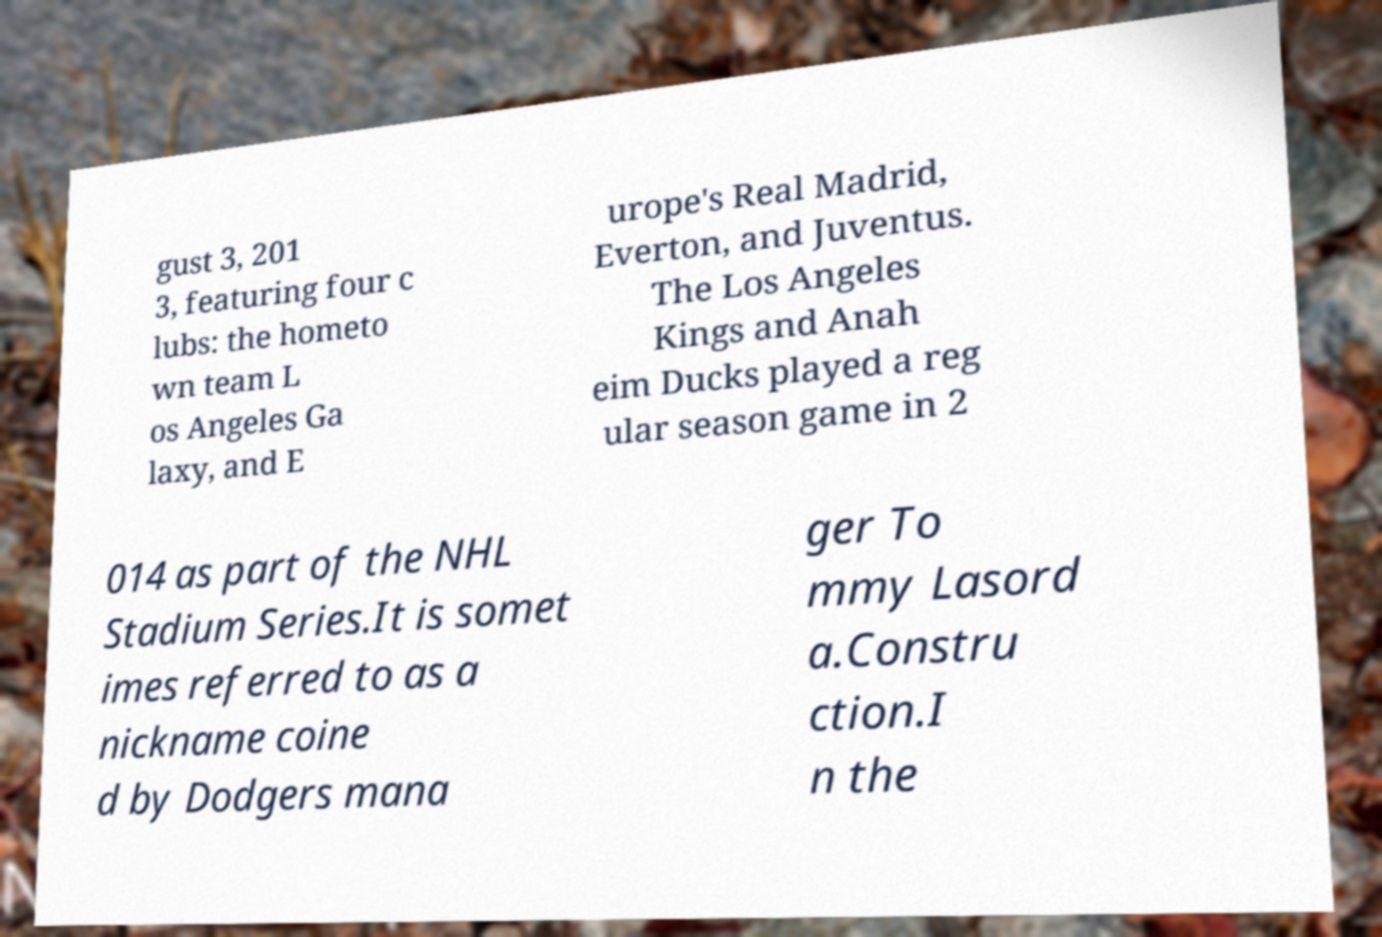For documentation purposes, I need the text within this image transcribed. Could you provide that? gust 3, 201 3, featuring four c lubs: the hometo wn team L os Angeles Ga laxy, and E urope's Real Madrid, Everton, and Juventus. The Los Angeles Kings and Anah eim Ducks played a reg ular season game in 2 014 as part of the NHL Stadium Series.It is somet imes referred to as a nickname coine d by Dodgers mana ger To mmy Lasord a.Constru ction.I n the 